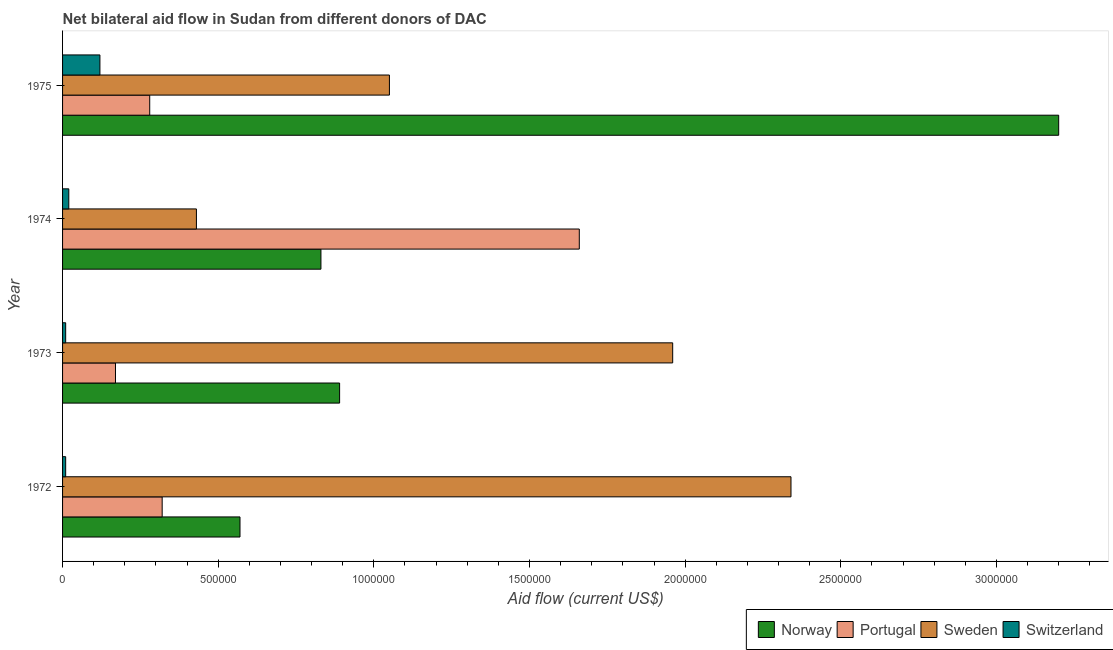How many different coloured bars are there?
Your response must be concise. 4. How many bars are there on the 3rd tick from the bottom?
Keep it short and to the point. 4. What is the label of the 3rd group of bars from the top?
Your response must be concise. 1973. In how many cases, is the number of bars for a given year not equal to the number of legend labels?
Make the answer very short. 0. What is the amount of aid given by portugal in 1975?
Offer a terse response. 2.80e+05. Across all years, what is the maximum amount of aid given by norway?
Keep it short and to the point. 3.20e+06. Across all years, what is the minimum amount of aid given by sweden?
Your response must be concise. 4.30e+05. In which year was the amount of aid given by norway maximum?
Keep it short and to the point. 1975. What is the total amount of aid given by norway in the graph?
Provide a short and direct response. 5.49e+06. What is the difference between the amount of aid given by switzerland in 1973 and that in 1974?
Offer a very short reply. -10000. What is the difference between the amount of aid given by portugal in 1974 and the amount of aid given by norway in 1973?
Provide a short and direct response. 7.70e+05. What is the average amount of aid given by norway per year?
Provide a succinct answer. 1.37e+06. In the year 1972, what is the difference between the amount of aid given by norway and amount of aid given by sweden?
Offer a very short reply. -1.77e+06. What is the ratio of the amount of aid given by portugal in 1974 to that in 1975?
Your response must be concise. 5.93. Is the amount of aid given by switzerland in 1972 less than that in 1973?
Provide a succinct answer. No. What is the difference between the highest and the lowest amount of aid given by norway?
Offer a terse response. 2.63e+06. In how many years, is the amount of aid given by switzerland greater than the average amount of aid given by switzerland taken over all years?
Make the answer very short. 1. Is the sum of the amount of aid given by sweden in 1973 and 1974 greater than the maximum amount of aid given by portugal across all years?
Offer a very short reply. Yes. What does the 4th bar from the top in 1974 represents?
Offer a very short reply. Norway. What does the 3rd bar from the bottom in 1973 represents?
Ensure brevity in your answer.  Sweden. How many bars are there?
Offer a very short reply. 16. Are all the bars in the graph horizontal?
Provide a succinct answer. Yes. How many years are there in the graph?
Offer a terse response. 4. Does the graph contain any zero values?
Make the answer very short. No. Where does the legend appear in the graph?
Provide a short and direct response. Bottom right. How are the legend labels stacked?
Provide a succinct answer. Horizontal. What is the title of the graph?
Provide a short and direct response. Net bilateral aid flow in Sudan from different donors of DAC. What is the label or title of the X-axis?
Provide a succinct answer. Aid flow (current US$). What is the Aid flow (current US$) in Norway in 1972?
Provide a short and direct response. 5.70e+05. What is the Aid flow (current US$) in Sweden in 1972?
Offer a terse response. 2.34e+06. What is the Aid flow (current US$) of Norway in 1973?
Provide a succinct answer. 8.90e+05. What is the Aid flow (current US$) of Portugal in 1973?
Your answer should be compact. 1.70e+05. What is the Aid flow (current US$) of Sweden in 1973?
Keep it short and to the point. 1.96e+06. What is the Aid flow (current US$) of Norway in 1974?
Keep it short and to the point. 8.30e+05. What is the Aid flow (current US$) of Portugal in 1974?
Make the answer very short. 1.66e+06. What is the Aid flow (current US$) in Sweden in 1974?
Offer a terse response. 4.30e+05. What is the Aid flow (current US$) of Norway in 1975?
Provide a succinct answer. 3.20e+06. What is the Aid flow (current US$) in Portugal in 1975?
Make the answer very short. 2.80e+05. What is the Aid flow (current US$) in Sweden in 1975?
Offer a very short reply. 1.05e+06. What is the Aid flow (current US$) in Switzerland in 1975?
Your response must be concise. 1.20e+05. Across all years, what is the maximum Aid flow (current US$) in Norway?
Ensure brevity in your answer.  3.20e+06. Across all years, what is the maximum Aid flow (current US$) in Portugal?
Your answer should be compact. 1.66e+06. Across all years, what is the maximum Aid flow (current US$) of Sweden?
Provide a succinct answer. 2.34e+06. Across all years, what is the minimum Aid flow (current US$) in Norway?
Provide a succinct answer. 5.70e+05. Across all years, what is the minimum Aid flow (current US$) in Portugal?
Your answer should be compact. 1.70e+05. Across all years, what is the minimum Aid flow (current US$) of Switzerland?
Make the answer very short. 10000. What is the total Aid flow (current US$) of Norway in the graph?
Your answer should be compact. 5.49e+06. What is the total Aid flow (current US$) in Portugal in the graph?
Offer a very short reply. 2.43e+06. What is the total Aid flow (current US$) of Sweden in the graph?
Offer a terse response. 5.78e+06. What is the total Aid flow (current US$) in Switzerland in the graph?
Offer a terse response. 1.60e+05. What is the difference between the Aid flow (current US$) in Norway in 1972 and that in 1973?
Keep it short and to the point. -3.20e+05. What is the difference between the Aid flow (current US$) in Portugal in 1972 and that in 1973?
Offer a terse response. 1.50e+05. What is the difference between the Aid flow (current US$) in Sweden in 1972 and that in 1973?
Provide a succinct answer. 3.80e+05. What is the difference between the Aid flow (current US$) of Norway in 1972 and that in 1974?
Give a very brief answer. -2.60e+05. What is the difference between the Aid flow (current US$) of Portugal in 1972 and that in 1974?
Ensure brevity in your answer.  -1.34e+06. What is the difference between the Aid flow (current US$) of Sweden in 1972 and that in 1974?
Provide a short and direct response. 1.91e+06. What is the difference between the Aid flow (current US$) of Switzerland in 1972 and that in 1974?
Your answer should be very brief. -10000. What is the difference between the Aid flow (current US$) in Norway in 1972 and that in 1975?
Offer a very short reply. -2.63e+06. What is the difference between the Aid flow (current US$) in Sweden in 1972 and that in 1975?
Ensure brevity in your answer.  1.29e+06. What is the difference between the Aid flow (current US$) of Switzerland in 1972 and that in 1975?
Provide a short and direct response. -1.10e+05. What is the difference between the Aid flow (current US$) of Norway in 1973 and that in 1974?
Offer a very short reply. 6.00e+04. What is the difference between the Aid flow (current US$) in Portugal in 1973 and that in 1974?
Give a very brief answer. -1.49e+06. What is the difference between the Aid flow (current US$) of Sweden in 1973 and that in 1974?
Keep it short and to the point. 1.53e+06. What is the difference between the Aid flow (current US$) in Switzerland in 1973 and that in 1974?
Offer a very short reply. -10000. What is the difference between the Aid flow (current US$) in Norway in 1973 and that in 1975?
Offer a very short reply. -2.31e+06. What is the difference between the Aid flow (current US$) in Portugal in 1973 and that in 1975?
Keep it short and to the point. -1.10e+05. What is the difference between the Aid flow (current US$) of Sweden in 1973 and that in 1975?
Make the answer very short. 9.10e+05. What is the difference between the Aid flow (current US$) in Switzerland in 1973 and that in 1975?
Your answer should be very brief. -1.10e+05. What is the difference between the Aid flow (current US$) in Norway in 1974 and that in 1975?
Make the answer very short. -2.37e+06. What is the difference between the Aid flow (current US$) in Portugal in 1974 and that in 1975?
Keep it short and to the point. 1.38e+06. What is the difference between the Aid flow (current US$) of Sweden in 1974 and that in 1975?
Your answer should be very brief. -6.20e+05. What is the difference between the Aid flow (current US$) of Switzerland in 1974 and that in 1975?
Your answer should be very brief. -1.00e+05. What is the difference between the Aid flow (current US$) of Norway in 1972 and the Aid flow (current US$) of Sweden in 1973?
Provide a short and direct response. -1.39e+06. What is the difference between the Aid flow (current US$) in Norway in 1972 and the Aid flow (current US$) in Switzerland in 1973?
Your answer should be very brief. 5.60e+05. What is the difference between the Aid flow (current US$) in Portugal in 1972 and the Aid flow (current US$) in Sweden in 1973?
Provide a short and direct response. -1.64e+06. What is the difference between the Aid flow (current US$) in Sweden in 1972 and the Aid flow (current US$) in Switzerland in 1973?
Give a very brief answer. 2.33e+06. What is the difference between the Aid flow (current US$) in Norway in 1972 and the Aid flow (current US$) in Portugal in 1974?
Provide a short and direct response. -1.09e+06. What is the difference between the Aid flow (current US$) of Norway in 1972 and the Aid flow (current US$) of Switzerland in 1974?
Your answer should be compact. 5.50e+05. What is the difference between the Aid flow (current US$) in Portugal in 1972 and the Aid flow (current US$) in Sweden in 1974?
Provide a short and direct response. -1.10e+05. What is the difference between the Aid flow (current US$) in Sweden in 1972 and the Aid flow (current US$) in Switzerland in 1974?
Your answer should be compact. 2.32e+06. What is the difference between the Aid flow (current US$) in Norway in 1972 and the Aid flow (current US$) in Sweden in 1975?
Offer a very short reply. -4.80e+05. What is the difference between the Aid flow (current US$) in Norway in 1972 and the Aid flow (current US$) in Switzerland in 1975?
Provide a short and direct response. 4.50e+05. What is the difference between the Aid flow (current US$) in Portugal in 1972 and the Aid flow (current US$) in Sweden in 1975?
Keep it short and to the point. -7.30e+05. What is the difference between the Aid flow (current US$) of Sweden in 1972 and the Aid flow (current US$) of Switzerland in 1975?
Your answer should be very brief. 2.22e+06. What is the difference between the Aid flow (current US$) in Norway in 1973 and the Aid flow (current US$) in Portugal in 1974?
Offer a very short reply. -7.70e+05. What is the difference between the Aid flow (current US$) of Norway in 1973 and the Aid flow (current US$) of Sweden in 1974?
Provide a succinct answer. 4.60e+05. What is the difference between the Aid flow (current US$) of Norway in 1973 and the Aid flow (current US$) of Switzerland in 1974?
Offer a terse response. 8.70e+05. What is the difference between the Aid flow (current US$) of Sweden in 1973 and the Aid flow (current US$) of Switzerland in 1974?
Your answer should be compact. 1.94e+06. What is the difference between the Aid flow (current US$) in Norway in 1973 and the Aid flow (current US$) in Portugal in 1975?
Your response must be concise. 6.10e+05. What is the difference between the Aid flow (current US$) in Norway in 1973 and the Aid flow (current US$) in Switzerland in 1975?
Your answer should be compact. 7.70e+05. What is the difference between the Aid flow (current US$) of Portugal in 1973 and the Aid flow (current US$) of Sweden in 1975?
Your answer should be very brief. -8.80e+05. What is the difference between the Aid flow (current US$) in Portugal in 1973 and the Aid flow (current US$) in Switzerland in 1975?
Provide a succinct answer. 5.00e+04. What is the difference between the Aid flow (current US$) of Sweden in 1973 and the Aid flow (current US$) of Switzerland in 1975?
Your answer should be compact. 1.84e+06. What is the difference between the Aid flow (current US$) of Norway in 1974 and the Aid flow (current US$) of Portugal in 1975?
Your response must be concise. 5.50e+05. What is the difference between the Aid flow (current US$) of Norway in 1974 and the Aid flow (current US$) of Switzerland in 1975?
Give a very brief answer. 7.10e+05. What is the difference between the Aid flow (current US$) of Portugal in 1974 and the Aid flow (current US$) of Switzerland in 1975?
Your answer should be compact. 1.54e+06. What is the difference between the Aid flow (current US$) of Sweden in 1974 and the Aid flow (current US$) of Switzerland in 1975?
Ensure brevity in your answer.  3.10e+05. What is the average Aid flow (current US$) of Norway per year?
Offer a very short reply. 1.37e+06. What is the average Aid flow (current US$) of Portugal per year?
Keep it short and to the point. 6.08e+05. What is the average Aid flow (current US$) of Sweden per year?
Give a very brief answer. 1.44e+06. In the year 1972, what is the difference between the Aid flow (current US$) in Norway and Aid flow (current US$) in Portugal?
Offer a terse response. 2.50e+05. In the year 1972, what is the difference between the Aid flow (current US$) of Norway and Aid flow (current US$) of Sweden?
Your answer should be very brief. -1.77e+06. In the year 1972, what is the difference between the Aid flow (current US$) of Norway and Aid flow (current US$) of Switzerland?
Make the answer very short. 5.60e+05. In the year 1972, what is the difference between the Aid flow (current US$) of Portugal and Aid flow (current US$) of Sweden?
Give a very brief answer. -2.02e+06. In the year 1972, what is the difference between the Aid flow (current US$) in Sweden and Aid flow (current US$) in Switzerland?
Offer a very short reply. 2.33e+06. In the year 1973, what is the difference between the Aid flow (current US$) of Norway and Aid flow (current US$) of Portugal?
Offer a terse response. 7.20e+05. In the year 1973, what is the difference between the Aid flow (current US$) of Norway and Aid flow (current US$) of Sweden?
Your response must be concise. -1.07e+06. In the year 1973, what is the difference between the Aid flow (current US$) in Norway and Aid flow (current US$) in Switzerland?
Your answer should be very brief. 8.80e+05. In the year 1973, what is the difference between the Aid flow (current US$) in Portugal and Aid flow (current US$) in Sweden?
Give a very brief answer. -1.79e+06. In the year 1973, what is the difference between the Aid flow (current US$) of Sweden and Aid flow (current US$) of Switzerland?
Your answer should be compact. 1.95e+06. In the year 1974, what is the difference between the Aid flow (current US$) of Norway and Aid flow (current US$) of Portugal?
Ensure brevity in your answer.  -8.30e+05. In the year 1974, what is the difference between the Aid flow (current US$) of Norway and Aid flow (current US$) of Sweden?
Give a very brief answer. 4.00e+05. In the year 1974, what is the difference between the Aid flow (current US$) of Norway and Aid flow (current US$) of Switzerland?
Provide a short and direct response. 8.10e+05. In the year 1974, what is the difference between the Aid flow (current US$) in Portugal and Aid flow (current US$) in Sweden?
Provide a short and direct response. 1.23e+06. In the year 1974, what is the difference between the Aid flow (current US$) of Portugal and Aid flow (current US$) of Switzerland?
Your response must be concise. 1.64e+06. In the year 1975, what is the difference between the Aid flow (current US$) in Norway and Aid flow (current US$) in Portugal?
Provide a short and direct response. 2.92e+06. In the year 1975, what is the difference between the Aid flow (current US$) in Norway and Aid flow (current US$) in Sweden?
Your response must be concise. 2.15e+06. In the year 1975, what is the difference between the Aid flow (current US$) in Norway and Aid flow (current US$) in Switzerland?
Provide a succinct answer. 3.08e+06. In the year 1975, what is the difference between the Aid flow (current US$) of Portugal and Aid flow (current US$) of Sweden?
Give a very brief answer. -7.70e+05. In the year 1975, what is the difference between the Aid flow (current US$) in Sweden and Aid flow (current US$) in Switzerland?
Your answer should be very brief. 9.30e+05. What is the ratio of the Aid flow (current US$) in Norway in 1972 to that in 1973?
Offer a very short reply. 0.64. What is the ratio of the Aid flow (current US$) in Portugal in 1972 to that in 1973?
Your response must be concise. 1.88. What is the ratio of the Aid flow (current US$) in Sweden in 1972 to that in 1973?
Offer a terse response. 1.19. What is the ratio of the Aid flow (current US$) of Switzerland in 1972 to that in 1973?
Offer a very short reply. 1. What is the ratio of the Aid flow (current US$) of Norway in 1972 to that in 1974?
Keep it short and to the point. 0.69. What is the ratio of the Aid flow (current US$) in Portugal in 1972 to that in 1974?
Your answer should be compact. 0.19. What is the ratio of the Aid flow (current US$) in Sweden in 1972 to that in 1974?
Your answer should be compact. 5.44. What is the ratio of the Aid flow (current US$) in Switzerland in 1972 to that in 1974?
Offer a very short reply. 0.5. What is the ratio of the Aid flow (current US$) in Norway in 1972 to that in 1975?
Provide a succinct answer. 0.18. What is the ratio of the Aid flow (current US$) of Sweden in 1972 to that in 1975?
Your answer should be very brief. 2.23. What is the ratio of the Aid flow (current US$) of Switzerland in 1972 to that in 1975?
Your answer should be compact. 0.08. What is the ratio of the Aid flow (current US$) of Norway in 1973 to that in 1974?
Your answer should be very brief. 1.07. What is the ratio of the Aid flow (current US$) in Portugal in 1973 to that in 1974?
Provide a short and direct response. 0.1. What is the ratio of the Aid flow (current US$) of Sweden in 1973 to that in 1974?
Offer a very short reply. 4.56. What is the ratio of the Aid flow (current US$) of Switzerland in 1973 to that in 1974?
Keep it short and to the point. 0.5. What is the ratio of the Aid flow (current US$) in Norway in 1973 to that in 1975?
Make the answer very short. 0.28. What is the ratio of the Aid flow (current US$) in Portugal in 1973 to that in 1975?
Provide a succinct answer. 0.61. What is the ratio of the Aid flow (current US$) in Sweden in 1973 to that in 1975?
Keep it short and to the point. 1.87. What is the ratio of the Aid flow (current US$) of Switzerland in 1973 to that in 1975?
Keep it short and to the point. 0.08. What is the ratio of the Aid flow (current US$) in Norway in 1974 to that in 1975?
Offer a terse response. 0.26. What is the ratio of the Aid flow (current US$) of Portugal in 1974 to that in 1975?
Ensure brevity in your answer.  5.93. What is the ratio of the Aid flow (current US$) in Sweden in 1974 to that in 1975?
Offer a terse response. 0.41. What is the ratio of the Aid flow (current US$) in Switzerland in 1974 to that in 1975?
Offer a very short reply. 0.17. What is the difference between the highest and the second highest Aid flow (current US$) in Norway?
Your answer should be compact. 2.31e+06. What is the difference between the highest and the second highest Aid flow (current US$) of Portugal?
Your answer should be compact. 1.34e+06. What is the difference between the highest and the lowest Aid flow (current US$) in Norway?
Provide a short and direct response. 2.63e+06. What is the difference between the highest and the lowest Aid flow (current US$) of Portugal?
Offer a terse response. 1.49e+06. What is the difference between the highest and the lowest Aid flow (current US$) of Sweden?
Make the answer very short. 1.91e+06. 